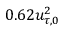<formula> <loc_0><loc_0><loc_500><loc_500>0 . 6 2 u _ { \tau , 0 } ^ { 2 }</formula> 